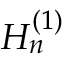Convert formula to latex. <formula><loc_0><loc_0><loc_500><loc_500>H _ { n } ^ { ( 1 ) }</formula> 